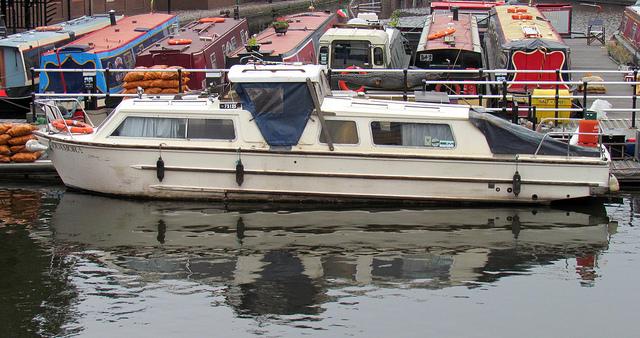Could someone live on this boat?
Keep it brief. Yes. Are there a lot of boats here?
Quick response, please. Yes. How many boats are in this scene?
Quick response, please. 1. Does this look like a new boat?
Answer briefly. No. What is on the deck of the closer boat?
Answer briefly. Life preserver. 